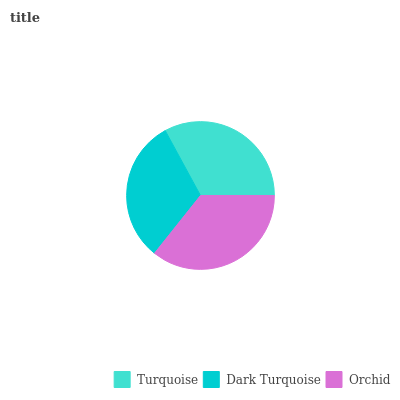Is Dark Turquoise the minimum?
Answer yes or no. Yes. Is Orchid the maximum?
Answer yes or no. Yes. Is Orchid the minimum?
Answer yes or no. No. Is Dark Turquoise the maximum?
Answer yes or no. No. Is Orchid greater than Dark Turquoise?
Answer yes or no. Yes. Is Dark Turquoise less than Orchid?
Answer yes or no. Yes. Is Dark Turquoise greater than Orchid?
Answer yes or no. No. Is Orchid less than Dark Turquoise?
Answer yes or no. No. Is Turquoise the high median?
Answer yes or no. Yes. Is Turquoise the low median?
Answer yes or no. Yes. Is Dark Turquoise the high median?
Answer yes or no. No. Is Orchid the low median?
Answer yes or no. No. 